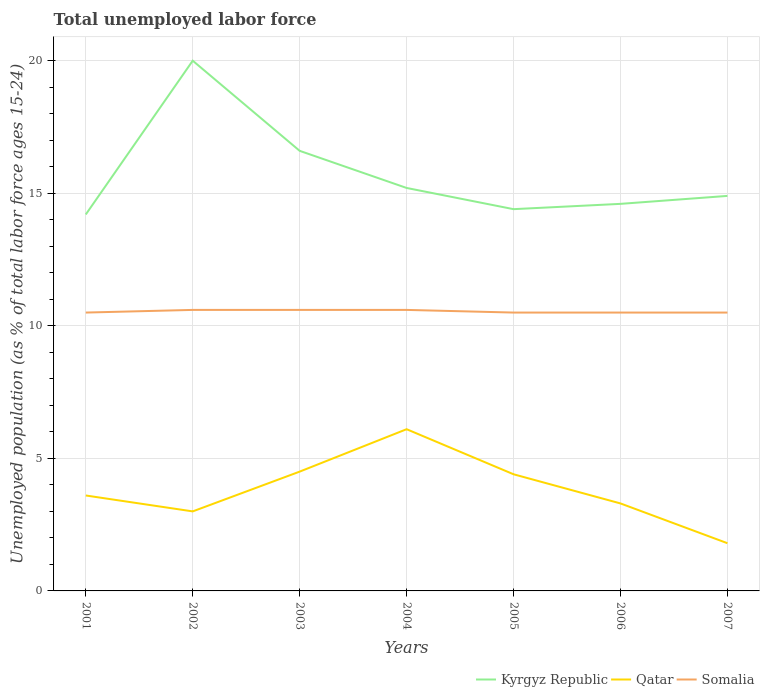Does the line corresponding to Kyrgyz Republic intersect with the line corresponding to Somalia?
Offer a very short reply. No. Is the number of lines equal to the number of legend labels?
Ensure brevity in your answer.  Yes. Across all years, what is the maximum percentage of unemployed population in in Kyrgyz Republic?
Ensure brevity in your answer.  14.2. In which year was the percentage of unemployed population in in Kyrgyz Republic maximum?
Your answer should be compact. 2001. What is the total percentage of unemployed population in in Kyrgyz Republic in the graph?
Offer a terse response. -0.2. What is the difference between the highest and the second highest percentage of unemployed population in in Kyrgyz Republic?
Your answer should be very brief. 5.8. What is the difference between the highest and the lowest percentage of unemployed population in in Kyrgyz Republic?
Provide a succinct answer. 2. Is the percentage of unemployed population in in Kyrgyz Republic strictly greater than the percentage of unemployed population in in Qatar over the years?
Give a very brief answer. No. Are the values on the major ticks of Y-axis written in scientific E-notation?
Offer a terse response. No. Where does the legend appear in the graph?
Your answer should be very brief. Bottom right. How many legend labels are there?
Keep it short and to the point. 3. What is the title of the graph?
Offer a very short reply. Total unemployed labor force. What is the label or title of the Y-axis?
Ensure brevity in your answer.  Unemployed population (as % of total labor force ages 15-24). What is the Unemployed population (as % of total labor force ages 15-24) in Kyrgyz Republic in 2001?
Ensure brevity in your answer.  14.2. What is the Unemployed population (as % of total labor force ages 15-24) of Qatar in 2001?
Make the answer very short. 3.6. What is the Unemployed population (as % of total labor force ages 15-24) of Somalia in 2002?
Provide a succinct answer. 10.6. What is the Unemployed population (as % of total labor force ages 15-24) in Kyrgyz Republic in 2003?
Provide a succinct answer. 16.6. What is the Unemployed population (as % of total labor force ages 15-24) of Somalia in 2003?
Offer a very short reply. 10.6. What is the Unemployed population (as % of total labor force ages 15-24) in Kyrgyz Republic in 2004?
Keep it short and to the point. 15.2. What is the Unemployed population (as % of total labor force ages 15-24) in Qatar in 2004?
Provide a short and direct response. 6.1. What is the Unemployed population (as % of total labor force ages 15-24) of Somalia in 2004?
Keep it short and to the point. 10.6. What is the Unemployed population (as % of total labor force ages 15-24) of Kyrgyz Republic in 2005?
Give a very brief answer. 14.4. What is the Unemployed population (as % of total labor force ages 15-24) in Qatar in 2005?
Make the answer very short. 4.4. What is the Unemployed population (as % of total labor force ages 15-24) in Kyrgyz Republic in 2006?
Your answer should be very brief. 14.6. What is the Unemployed population (as % of total labor force ages 15-24) in Qatar in 2006?
Make the answer very short. 3.3. What is the Unemployed population (as % of total labor force ages 15-24) in Somalia in 2006?
Keep it short and to the point. 10.5. What is the Unemployed population (as % of total labor force ages 15-24) of Kyrgyz Republic in 2007?
Keep it short and to the point. 14.9. What is the Unemployed population (as % of total labor force ages 15-24) in Qatar in 2007?
Your answer should be compact. 1.8. What is the Unemployed population (as % of total labor force ages 15-24) of Somalia in 2007?
Ensure brevity in your answer.  10.5. Across all years, what is the maximum Unemployed population (as % of total labor force ages 15-24) of Qatar?
Ensure brevity in your answer.  6.1. Across all years, what is the maximum Unemployed population (as % of total labor force ages 15-24) in Somalia?
Make the answer very short. 10.6. Across all years, what is the minimum Unemployed population (as % of total labor force ages 15-24) of Kyrgyz Republic?
Your answer should be compact. 14.2. Across all years, what is the minimum Unemployed population (as % of total labor force ages 15-24) in Qatar?
Give a very brief answer. 1.8. What is the total Unemployed population (as % of total labor force ages 15-24) of Kyrgyz Republic in the graph?
Offer a terse response. 109.9. What is the total Unemployed population (as % of total labor force ages 15-24) of Qatar in the graph?
Keep it short and to the point. 26.7. What is the total Unemployed population (as % of total labor force ages 15-24) in Somalia in the graph?
Keep it short and to the point. 73.8. What is the difference between the Unemployed population (as % of total labor force ages 15-24) of Qatar in 2001 and that in 2002?
Your response must be concise. 0.6. What is the difference between the Unemployed population (as % of total labor force ages 15-24) in Kyrgyz Republic in 2001 and that in 2003?
Make the answer very short. -2.4. What is the difference between the Unemployed population (as % of total labor force ages 15-24) in Qatar in 2001 and that in 2003?
Give a very brief answer. -0.9. What is the difference between the Unemployed population (as % of total labor force ages 15-24) in Kyrgyz Republic in 2001 and that in 2004?
Give a very brief answer. -1. What is the difference between the Unemployed population (as % of total labor force ages 15-24) of Somalia in 2001 and that in 2004?
Your response must be concise. -0.1. What is the difference between the Unemployed population (as % of total labor force ages 15-24) in Somalia in 2001 and that in 2005?
Provide a succinct answer. 0. What is the difference between the Unemployed population (as % of total labor force ages 15-24) in Kyrgyz Republic in 2001 and that in 2006?
Make the answer very short. -0.4. What is the difference between the Unemployed population (as % of total labor force ages 15-24) of Kyrgyz Republic in 2001 and that in 2007?
Keep it short and to the point. -0.7. What is the difference between the Unemployed population (as % of total labor force ages 15-24) of Qatar in 2002 and that in 2003?
Your answer should be compact. -1.5. What is the difference between the Unemployed population (as % of total labor force ages 15-24) of Somalia in 2002 and that in 2003?
Your answer should be compact. 0. What is the difference between the Unemployed population (as % of total labor force ages 15-24) of Kyrgyz Republic in 2002 and that in 2004?
Your answer should be compact. 4.8. What is the difference between the Unemployed population (as % of total labor force ages 15-24) of Kyrgyz Republic in 2002 and that in 2006?
Provide a short and direct response. 5.4. What is the difference between the Unemployed population (as % of total labor force ages 15-24) of Qatar in 2002 and that in 2006?
Offer a terse response. -0.3. What is the difference between the Unemployed population (as % of total labor force ages 15-24) of Qatar in 2002 and that in 2007?
Keep it short and to the point. 1.2. What is the difference between the Unemployed population (as % of total labor force ages 15-24) in Somalia in 2002 and that in 2007?
Ensure brevity in your answer.  0.1. What is the difference between the Unemployed population (as % of total labor force ages 15-24) in Kyrgyz Republic in 2003 and that in 2004?
Your answer should be compact. 1.4. What is the difference between the Unemployed population (as % of total labor force ages 15-24) of Somalia in 2003 and that in 2004?
Your answer should be very brief. 0. What is the difference between the Unemployed population (as % of total labor force ages 15-24) of Kyrgyz Republic in 2003 and that in 2005?
Your answer should be very brief. 2.2. What is the difference between the Unemployed population (as % of total labor force ages 15-24) in Qatar in 2003 and that in 2005?
Provide a succinct answer. 0.1. What is the difference between the Unemployed population (as % of total labor force ages 15-24) in Somalia in 2003 and that in 2005?
Offer a terse response. 0.1. What is the difference between the Unemployed population (as % of total labor force ages 15-24) in Kyrgyz Republic in 2003 and that in 2006?
Offer a very short reply. 2. What is the difference between the Unemployed population (as % of total labor force ages 15-24) of Qatar in 2003 and that in 2006?
Make the answer very short. 1.2. What is the difference between the Unemployed population (as % of total labor force ages 15-24) in Somalia in 2003 and that in 2006?
Your answer should be compact. 0.1. What is the difference between the Unemployed population (as % of total labor force ages 15-24) in Qatar in 2003 and that in 2007?
Provide a short and direct response. 2.7. What is the difference between the Unemployed population (as % of total labor force ages 15-24) in Kyrgyz Republic in 2004 and that in 2005?
Your response must be concise. 0.8. What is the difference between the Unemployed population (as % of total labor force ages 15-24) of Kyrgyz Republic in 2004 and that in 2006?
Offer a terse response. 0.6. What is the difference between the Unemployed population (as % of total labor force ages 15-24) in Qatar in 2004 and that in 2006?
Your response must be concise. 2.8. What is the difference between the Unemployed population (as % of total labor force ages 15-24) in Somalia in 2004 and that in 2007?
Your answer should be compact. 0.1. What is the difference between the Unemployed population (as % of total labor force ages 15-24) of Qatar in 2005 and that in 2007?
Make the answer very short. 2.6. What is the difference between the Unemployed population (as % of total labor force ages 15-24) of Somalia in 2005 and that in 2007?
Ensure brevity in your answer.  0. What is the difference between the Unemployed population (as % of total labor force ages 15-24) in Somalia in 2006 and that in 2007?
Your answer should be very brief. 0. What is the difference between the Unemployed population (as % of total labor force ages 15-24) in Kyrgyz Republic in 2001 and the Unemployed population (as % of total labor force ages 15-24) in Qatar in 2002?
Your answer should be very brief. 11.2. What is the difference between the Unemployed population (as % of total labor force ages 15-24) in Qatar in 2001 and the Unemployed population (as % of total labor force ages 15-24) in Somalia in 2002?
Ensure brevity in your answer.  -7. What is the difference between the Unemployed population (as % of total labor force ages 15-24) of Kyrgyz Republic in 2001 and the Unemployed population (as % of total labor force ages 15-24) of Qatar in 2003?
Offer a very short reply. 9.7. What is the difference between the Unemployed population (as % of total labor force ages 15-24) of Kyrgyz Republic in 2001 and the Unemployed population (as % of total labor force ages 15-24) of Somalia in 2003?
Your answer should be very brief. 3.6. What is the difference between the Unemployed population (as % of total labor force ages 15-24) of Kyrgyz Republic in 2001 and the Unemployed population (as % of total labor force ages 15-24) of Somalia in 2004?
Offer a very short reply. 3.6. What is the difference between the Unemployed population (as % of total labor force ages 15-24) in Kyrgyz Republic in 2001 and the Unemployed population (as % of total labor force ages 15-24) in Qatar in 2005?
Give a very brief answer. 9.8. What is the difference between the Unemployed population (as % of total labor force ages 15-24) in Kyrgyz Republic in 2001 and the Unemployed population (as % of total labor force ages 15-24) in Somalia in 2005?
Offer a terse response. 3.7. What is the difference between the Unemployed population (as % of total labor force ages 15-24) of Kyrgyz Republic in 2001 and the Unemployed population (as % of total labor force ages 15-24) of Somalia in 2006?
Your response must be concise. 3.7. What is the difference between the Unemployed population (as % of total labor force ages 15-24) in Qatar in 2001 and the Unemployed population (as % of total labor force ages 15-24) in Somalia in 2006?
Offer a terse response. -6.9. What is the difference between the Unemployed population (as % of total labor force ages 15-24) of Kyrgyz Republic in 2001 and the Unemployed population (as % of total labor force ages 15-24) of Qatar in 2007?
Provide a succinct answer. 12.4. What is the difference between the Unemployed population (as % of total labor force ages 15-24) in Kyrgyz Republic in 2001 and the Unemployed population (as % of total labor force ages 15-24) in Somalia in 2007?
Offer a terse response. 3.7. What is the difference between the Unemployed population (as % of total labor force ages 15-24) of Qatar in 2001 and the Unemployed population (as % of total labor force ages 15-24) of Somalia in 2007?
Offer a very short reply. -6.9. What is the difference between the Unemployed population (as % of total labor force ages 15-24) of Kyrgyz Republic in 2002 and the Unemployed population (as % of total labor force ages 15-24) of Qatar in 2003?
Offer a terse response. 15.5. What is the difference between the Unemployed population (as % of total labor force ages 15-24) in Kyrgyz Republic in 2002 and the Unemployed population (as % of total labor force ages 15-24) in Qatar in 2004?
Provide a succinct answer. 13.9. What is the difference between the Unemployed population (as % of total labor force ages 15-24) of Kyrgyz Republic in 2002 and the Unemployed population (as % of total labor force ages 15-24) of Somalia in 2005?
Offer a very short reply. 9.5. What is the difference between the Unemployed population (as % of total labor force ages 15-24) in Qatar in 2002 and the Unemployed population (as % of total labor force ages 15-24) in Somalia in 2005?
Your answer should be compact. -7.5. What is the difference between the Unemployed population (as % of total labor force ages 15-24) in Kyrgyz Republic in 2002 and the Unemployed population (as % of total labor force ages 15-24) in Qatar in 2006?
Your answer should be very brief. 16.7. What is the difference between the Unemployed population (as % of total labor force ages 15-24) in Qatar in 2002 and the Unemployed population (as % of total labor force ages 15-24) in Somalia in 2006?
Your answer should be compact. -7.5. What is the difference between the Unemployed population (as % of total labor force ages 15-24) of Kyrgyz Republic in 2002 and the Unemployed population (as % of total labor force ages 15-24) of Qatar in 2007?
Ensure brevity in your answer.  18.2. What is the difference between the Unemployed population (as % of total labor force ages 15-24) in Kyrgyz Republic in 2002 and the Unemployed population (as % of total labor force ages 15-24) in Somalia in 2007?
Keep it short and to the point. 9.5. What is the difference between the Unemployed population (as % of total labor force ages 15-24) in Kyrgyz Republic in 2003 and the Unemployed population (as % of total labor force ages 15-24) in Qatar in 2004?
Offer a very short reply. 10.5. What is the difference between the Unemployed population (as % of total labor force ages 15-24) of Kyrgyz Republic in 2003 and the Unemployed population (as % of total labor force ages 15-24) of Somalia in 2004?
Your response must be concise. 6. What is the difference between the Unemployed population (as % of total labor force ages 15-24) of Qatar in 2003 and the Unemployed population (as % of total labor force ages 15-24) of Somalia in 2004?
Offer a very short reply. -6.1. What is the difference between the Unemployed population (as % of total labor force ages 15-24) of Kyrgyz Republic in 2003 and the Unemployed population (as % of total labor force ages 15-24) of Somalia in 2005?
Your response must be concise. 6.1. What is the difference between the Unemployed population (as % of total labor force ages 15-24) in Qatar in 2003 and the Unemployed population (as % of total labor force ages 15-24) in Somalia in 2005?
Your answer should be compact. -6. What is the difference between the Unemployed population (as % of total labor force ages 15-24) of Kyrgyz Republic in 2003 and the Unemployed population (as % of total labor force ages 15-24) of Qatar in 2006?
Keep it short and to the point. 13.3. What is the difference between the Unemployed population (as % of total labor force ages 15-24) in Qatar in 2003 and the Unemployed population (as % of total labor force ages 15-24) in Somalia in 2006?
Your answer should be compact. -6. What is the difference between the Unemployed population (as % of total labor force ages 15-24) in Kyrgyz Republic in 2003 and the Unemployed population (as % of total labor force ages 15-24) in Qatar in 2007?
Provide a succinct answer. 14.8. What is the difference between the Unemployed population (as % of total labor force ages 15-24) in Qatar in 2003 and the Unemployed population (as % of total labor force ages 15-24) in Somalia in 2007?
Your answer should be compact. -6. What is the difference between the Unemployed population (as % of total labor force ages 15-24) of Kyrgyz Republic in 2004 and the Unemployed population (as % of total labor force ages 15-24) of Qatar in 2005?
Your answer should be very brief. 10.8. What is the difference between the Unemployed population (as % of total labor force ages 15-24) in Kyrgyz Republic in 2004 and the Unemployed population (as % of total labor force ages 15-24) in Somalia in 2005?
Ensure brevity in your answer.  4.7. What is the difference between the Unemployed population (as % of total labor force ages 15-24) of Qatar in 2004 and the Unemployed population (as % of total labor force ages 15-24) of Somalia in 2005?
Ensure brevity in your answer.  -4.4. What is the difference between the Unemployed population (as % of total labor force ages 15-24) of Kyrgyz Republic in 2004 and the Unemployed population (as % of total labor force ages 15-24) of Qatar in 2006?
Your answer should be very brief. 11.9. What is the difference between the Unemployed population (as % of total labor force ages 15-24) of Kyrgyz Republic in 2004 and the Unemployed population (as % of total labor force ages 15-24) of Somalia in 2006?
Your response must be concise. 4.7. What is the difference between the Unemployed population (as % of total labor force ages 15-24) of Kyrgyz Republic in 2004 and the Unemployed population (as % of total labor force ages 15-24) of Qatar in 2007?
Your answer should be compact. 13.4. What is the difference between the Unemployed population (as % of total labor force ages 15-24) in Kyrgyz Republic in 2005 and the Unemployed population (as % of total labor force ages 15-24) in Somalia in 2006?
Your answer should be very brief. 3.9. What is the difference between the Unemployed population (as % of total labor force ages 15-24) in Qatar in 2005 and the Unemployed population (as % of total labor force ages 15-24) in Somalia in 2006?
Your response must be concise. -6.1. What is the difference between the Unemployed population (as % of total labor force ages 15-24) in Kyrgyz Republic in 2005 and the Unemployed population (as % of total labor force ages 15-24) in Somalia in 2007?
Provide a succinct answer. 3.9. What is the difference between the Unemployed population (as % of total labor force ages 15-24) in Qatar in 2005 and the Unemployed population (as % of total labor force ages 15-24) in Somalia in 2007?
Give a very brief answer. -6.1. What is the difference between the Unemployed population (as % of total labor force ages 15-24) in Kyrgyz Republic in 2006 and the Unemployed population (as % of total labor force ages 15-24) in Qatar in 2007?
Your answer should be compact. 12.8. What is the difference between the Unemployed population (as % of total labor force ages 15-24) of Kyrgyz Republic in 2006 and the Unemployed population (as % of total labor force ages 15-24) of Somalia in 2007?
Your answer should be compact. 4.1. What is the difference between the Unemployed population (as % of total labor force ages 15-24) of Qatar in 2006 and the Unemployed population (as % of total labor force ages 15-24) of Somalia in 2007?
Give a very brief answer. -7.2. What is the average Unemployed population (as % of total labor force ages 15-24) of Qatar per year?
Offer a terse response. 3.81. What is the average Unemployed population (as % of total labor force ages 15-24) of Somalia per year?
Your answer should be very brief. 10.54. In the year 2001, what is the difference between the Unemployed population (as % of total labor force ages 15-24) in Kyrgyz Republic and Unemployed population (as % of total labor force ages 15-24) in Qatar?
Your response must be concise. 10.6. In the year 2001, what is the difference between the Unemployed population (as % of total labor force ages 15-24) in Kyrgyz Republic and Unemployed population (as % of total labor force ages 15-24) in Somalia?
Offer a terse response. 3.7. In the year 2001, what is the difference between the Unemployed population (as % of total labor force ages 15-24) of Qatar and Unemployed population (as % of total labor force ages 15-24) of Somalia?
Provide a succinct answer. -6.9. In the year 2002, what is the difference between the Unemployed population (as % of total labor force ages 15-24) of Kyrgyz Republic and Unemployed population (as % of total labor force ages 15-24) of Qatar?
Provide a short and direct response. 17. In the year 2003, what is the difference between the Unemployed population (as % of total labor force ages 15-24) in Kyrgyz Republic and Unemployed population (as % of total labor force ages 15-24) in Somalia?
Ensure brevity in your answer.  6. In the year 2003, what is the difference between the Unemployed population (as % of total labor force ages 15-24) in Qatar and Unemployed population (as % of total labor force ages 15-24) in Somalia?
Provide a succinct answer. -6.1. In the year 2004, what is the difference between the Unemployed population (as % of total labor force ages 15-24) of Qatar and Unemployed population (as % of total labor force ages 15-24) of Somalia?
Provide a succinct answer. -4.5. In the year 2005, what is the difference between the Unemployed population (as % of total labor force ages 15-24) in Kyrgyz Republic and Unemployed population (as % of total labor force ages 15-24) in Qatar?
Your answer should be very brief. 10. In the year 2005, what is the difference between the Unemployed population (as % of total labor force ages 15-24) in Kyrgyz Republic and Unemployed population (as % of total labor force ages 15-24) in Somalia?
Provide a short and direct response. 3.9. In the year 2006, what is the difference between the Unemployed population (as % of total labor force ages 15-24) of Kyrgyz Republic and Unemployed population (as % of total labor force ages 15-24) of Qatar?
Make the answer very short. 11.3. In the year 2006, what is the difference between the Unemployed population (as % of total labor force ages 15-24) in Kyrgyz Republic and Unemployed population (as % of total labor force ages 15-24) in Somalia?
Provide a short and direct response. 4.1. In the year 2006, what is the difference between the Unemployed population (as % of total labor force ages 15-24) of Qatar and Unemployed population (as % of total labor force ages 15-24) of Somalia?
Keep it short and to the point. -7.2. What is the ratio of the Unemployed population (as % of total labor force ages 15-24) in Kyrgyz Republic in 2001 to that in 2002?
Provide a short and direct response. 0.71. What is the ratio of the Unemployed population (as % of total labor force ages 15-24) in Qatar in 2001 to that in 2002?
Make the answer very short. 1.2. What is the ratio of the Unemployed population (as % of total labor force ages 15-24) in Somalia in 2001 to that in 2002?
Your answer should be very brief. 0.99. What is the ratio of the Unemployed population (as % of total labor force ages 15-24) in Kyrgyz Republic in 2001 to that in 2003?
Offer a very short reply. 0.86. What is the ratio of the Unemployed population (as % of total labor force ages 15-24) in Somalia in 2001 to that in 2003?
Ensure brevity in your answer.  0.99. What is the ratio of the Unemployed population (as % of total labor force ages 15-24) in Kyrgyz Republic in 2001 to that in 2004?
Keep it short and to the point. 0.93. What is the ratio of the Unemployed population (as % of total labor force ages 15-24) of Qatar in 2001 to that in 2004?
Keep it short and to the point. 0.59. What is the ratio of the Unemployed population (as % of total labor force ages 15-24) in Somalia in 2001 to that in 2004?
Give a very brief answer. 0.99. What is the ratio of the Unemployed population (as % of total labor force ages 15-24) of Kyrgyz Republic in 2001 to that in 2005?
Give a very brief answer. 0.99. What is the ratio of the Unemployed population (as % of total labor force ages 15-24) in Qatar in 2001 to that in 2005?
Keep it short and to the point. 0.82. What is the ratio of the Unemployed population (as % of total labor force ages 15-24) of Kyrgyz Republic in 2001 to that in 2006?
Ensure brevity in your answer.  0.97. What is the ratio of the Unemployed population (as % of total labor force ages 15-24) of Somalia in 2001 to that in 2006?
Give a very brief answer. 1. What is the ratio of the Unemployed population (as % of total labor force ages 15-24) in Kyrgyz Republic in 2001 to that in 2007?
Ensure brevity in your answer.  0.95. What is the ratio of the Unemployed population (as % of total labor force ages 15-24) of Kyrgyz Republic in 2002 to that in 2003?
Provide a succinct answer. 1.2. What is the ratio of the Unemployed population (as % of total labor force ages 15-24) of Qatar in 2002 to that in 2003?
Make the answer very short. 0.67. What is the ratio of the Unemployed population (as % of total labor force ages 15-24) in Kyrgyz Republic in 2002 to that in 2004?
Your answer should be compact. 1.32. What is the ratio of the Unemployed population (as % of total labor force ages 15-24) in Qatar in 2002 to that in 2004?
Give a very brief answer. 0.49. What is the ratio of the Unemployed population (as % of total labor force ages 15-24) of Kyrgyz Republic in 2002 to that in 2005?
Provide a succinct answer. 1.39. What is the ratio of the Unemployed population (as % of total labor force ages 15-24) in Qatar in 2002 to that in 2005?
Ensure brevity in your answer.  0.68. What is the ratio of the Unemployed population (as % of total labor force ages 15-24) in Somalia in 2002 to that in 2005?
Your response must be concise. 1.01. What is the ratio of the Unemployed population (as % of total labor force ages 15-24) in Kyrgyz Republic in 2002 to that in 2006?
Keep it short and to the point. 1.37. What is the ratio of the Unemployed population (as % of total labor force ages 15-24) in Somalia in 2002 to that in 2006?
Your answer should be very brief. 1.01. What is the ratio of the Unemployed population (as % of total labor force ages 15-24) of Kyrgyz Republic in 2002 to that in 2007?
Make the answer very short. 1.34. What is the ratio of the Unemployed population (as % of total labor force ages 15-24) in Qatar in 2002 to that in 2007?
Your answer should be compact. 1.67. What is the ratio of the Unemployed population (as % of total labor force ages 15-24) of Somalia in 2002 to that in 2007?
Provide a succinct answer. 1.01. What is the ratio of the Unemployed population (as % of total labor force ages 15-24) in Kyrgyz Republic in 2003 to that in 2004?
Your answer should be compact. 1.09. What is the ratio of the Unemployed population (as % of total labor force ages 15-24) in Qatar in 2003 to that in 2004?
Offer a very short reply. 0.74. What is the ratio of the Unemployed population (as % of total labor force ages 15-24) in Kyrgyz Republic in 2003 to that in 2005?
Provide a succinct answer. 1.15. What is the ratio of the Unemployed population (as % of total labor force ages 15-24) in Qatar in 2003 to that in 2005?
Keep it short and to the point. 1.02. What is the ratio of the Unemployed population (as % of total labor force ages 15-24) in Somalia in 2003 to that in 2005?
Provide a succinct answer. 1.01. What is the ratio of the Unemployed population (as % of total labor force ages 15-24) of Kyrgyz Republic in 2003 to that in 2006?
Make the answer very short. 1.14. What is the ratio of the Unemployed population (as % of total labor force ages 15-24) in Qatar in 2003 to that in 2006?
Provide a short and direct response. 1.36. What is the ratio of the Unemployed population (as % of total labor force ages 15-24) of Somalia in 2003 to that in 2006?
Ensure brevity in your answer.  1.01. What is the ratio of the Unemployed population (as % of total labor force ages 15-24) of Kyrgyz Republic in 2003 to that in 2007?
Ensure brevity in your answer.  1.11. What is the ratio of the Unemployed population (as % of total labor force ages 15-24) of Somalia in 2003 to that in 2007?
Your answer should be very brief. 1.01. What is the ratio of the Unemployed population (as % of total labor force ages 15-24) of Kyrgyz Republic in 2004 to that in 2005?
Your response must be concise. 1.06. What is the ratio of the Unemployed population (as % of total labor force ages 15-24) of Qatar in 2004 to that in 2005?
Keep it short and to the point. 1.39. What is the ratio of the Unemployed population (as % of total labor force ages 15-24) in Somalia in 2004 to that in 2005?
Ensure brevity in your answer.  1.01. What is the ratio of the Unemployed population (as % of total labor force ages 15-24) of Kyrgyz Republic in 2004 to that in 2006?
Keep it short and to the point. 1.04. What is the ratio of the Unemployed population (as % of total labor force ages 15-24) in Qatar in 2004 to that in 2006?
Provide a short and direct response. 1.85. What is the ratio of the Unemployed population (as % of total labor force ages 15-24) in Somalia in 2004 to that in 2006?
Offer a very short reply. 1.01. What is the ratio of the Unemployed population (as % of total labor force ages 15-24) of Kyrgyz Republic in 2004 to that in 2007?
Your response must be concise. 1.02. What is the ratio of the Unemployed population (as % of total labor force ages 15-24) of Qatar in 2004 to that in 2007?
Keep it short and to the point. 3.39. What is the ratio of the Unemployed population (as % of total labor force ages 15-24) of Somalia in 2004 to that in 2007?
Your answer should be compact. 1.01. What is the ratio of the Unemployed population (as % of total labor force ages 15-24) of Kyrgyz Republic in 2005 to that in 2006?
Your answer should be very brief. 0.99. What is the ratio of the Unemployed population (as % of total labor force ages 15-24) of Qatar in 2005 to that in 2006?
Ensure brevity in your answer.  1.33. What is the ratio of the Unemployed population (as % of total labor force ages 15-24) of Kyrgyz Republic in 2005 to that in 2007?
Your response must be concise. 0.97. What is the ratio of the Unemployed population (as % of total labor force ages 15-24) of Qatar in 2005 to that in 2007?
Offer a very short reply. 2.44. What is the ratio of the Unemployed population (as % of total labor force ages 15-24) in Somalia in 2005 to that in 2007?
Make the answer very short. 1. What is the ratio of the Unemployed population (as % of total labor force ages 15-24) in Kyrgyz Republic in 2006 to that in 2007?
Your answer should be very brief. 0.98. What is the ratio of the Unemployed population (as % of total labor force ages 15-24) of Qatar in 2006 to that in 2007?
Give a very brief answer. 1.83. What is the difference between the highest and the second highest Unemployed population (as % of total labor force ages 15-24) of Kyrgyz Republic?
Offer a terse response. 3.4. What is the difference between the highest and the lowest Unemployed population (as % of total labor force ages 15-24) of Kyrgyz Republic?
Keep it short and to the point. 5.8. What is the difference between the highest and the lowest Unemployed population (as % of total labor force ages 15-24) in Qatar?
Make the answer very short. 4.3. What is the difference between the highest and the lowest Unemployed population (as % of total labor force ages 15-24) in Somalia?
Your answer should be compact. 0.1. 